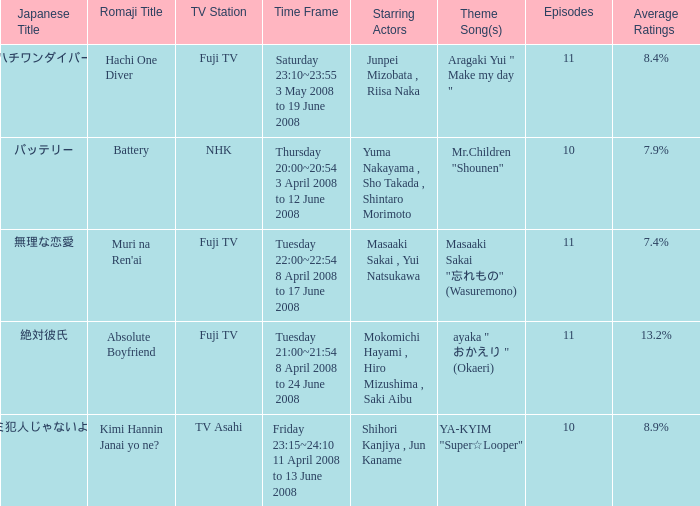Who were the starting actors in the time frame of  tuesday 22:00~22:54 8 april 2008 to 17 june 2008? Masaaki Sakai , Yui Natsukawa. 